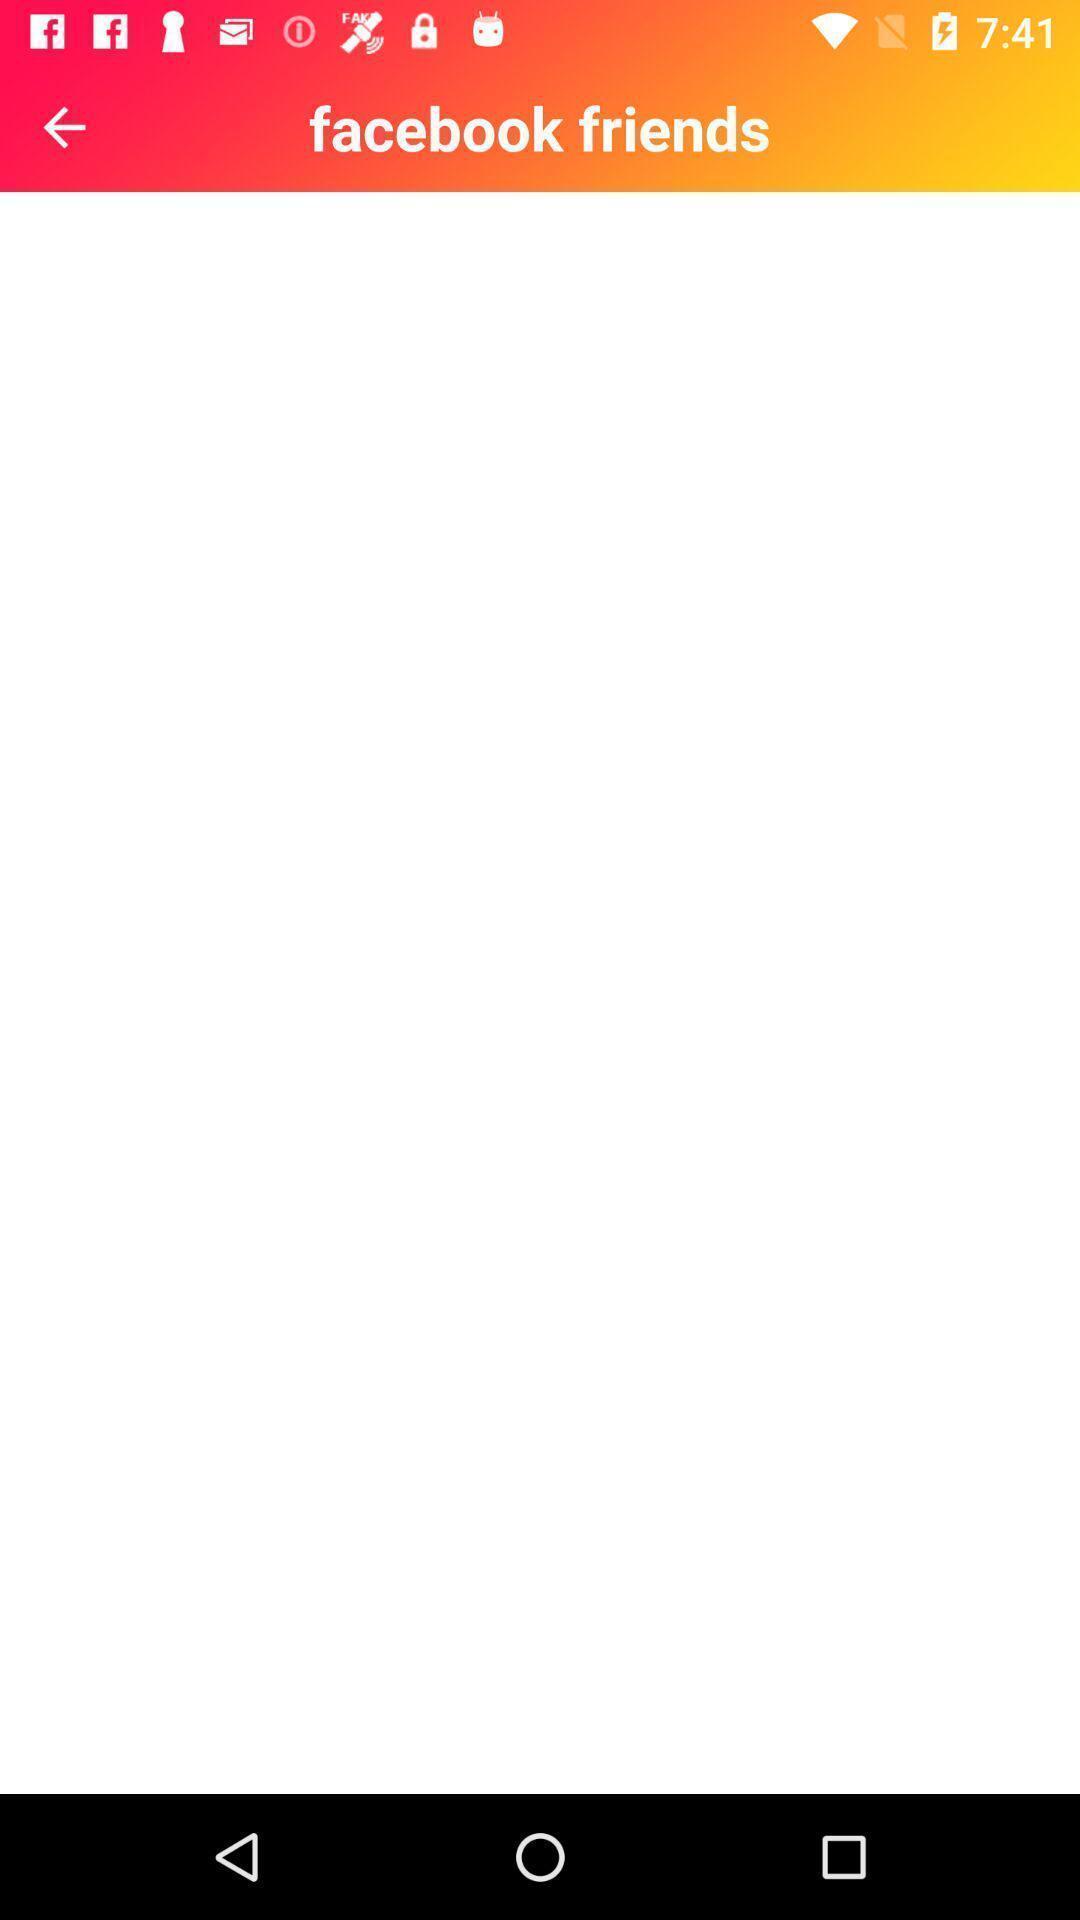Provide a description of this screenshot. Screen display friends page of a social app. 